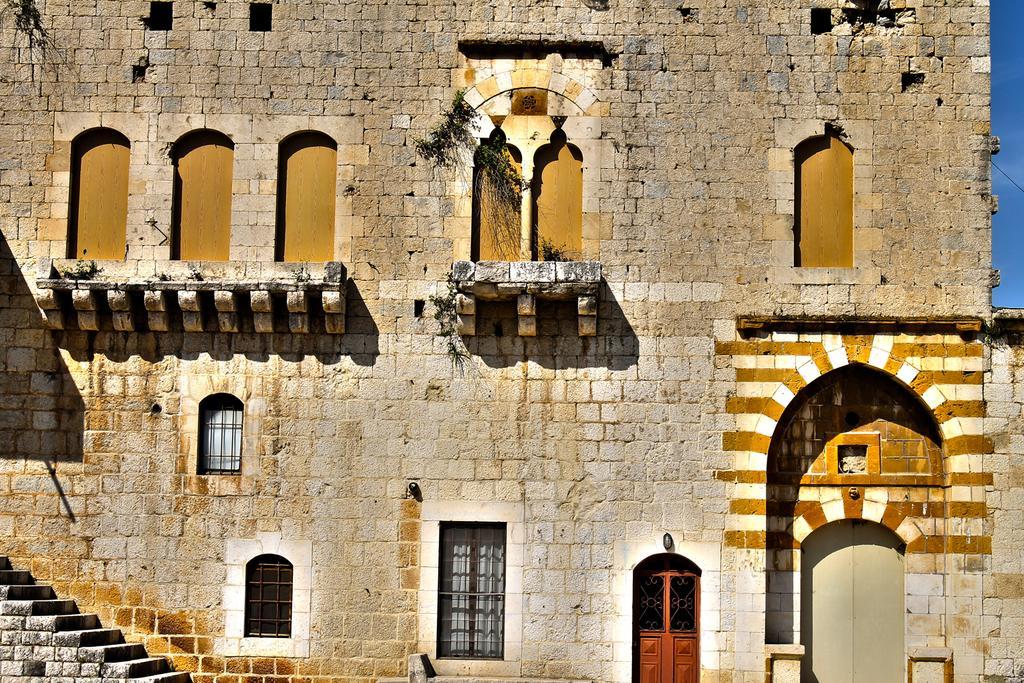What type of structure is visible in the image? There is a building in the image. What material was used to construct the building? The building is constructed with bricks. How many windows can be seen on the building? The building has many windows. Where are the stairs located in relation to the building? The stairs are on the left side of the building. What type of discovery was made by the farmer near the building in the image? There is no farmer or discovery mentioned in the image; it only features a building with stairs and many windows. 